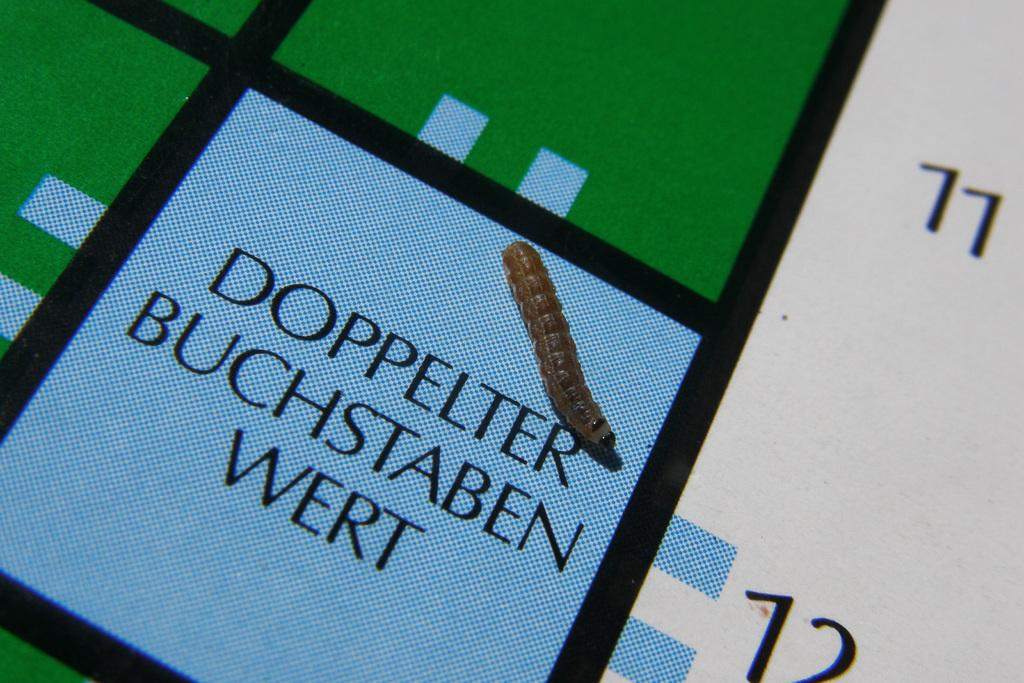What type of creature is present in the image? There is an insect in the image. Where is the insect located in the image? The insect is on a printed surface. What type of steel is used to create the wings of the insect in the image? The insect in the image does not have steel wings, as insects have natural wings made of chitin. 